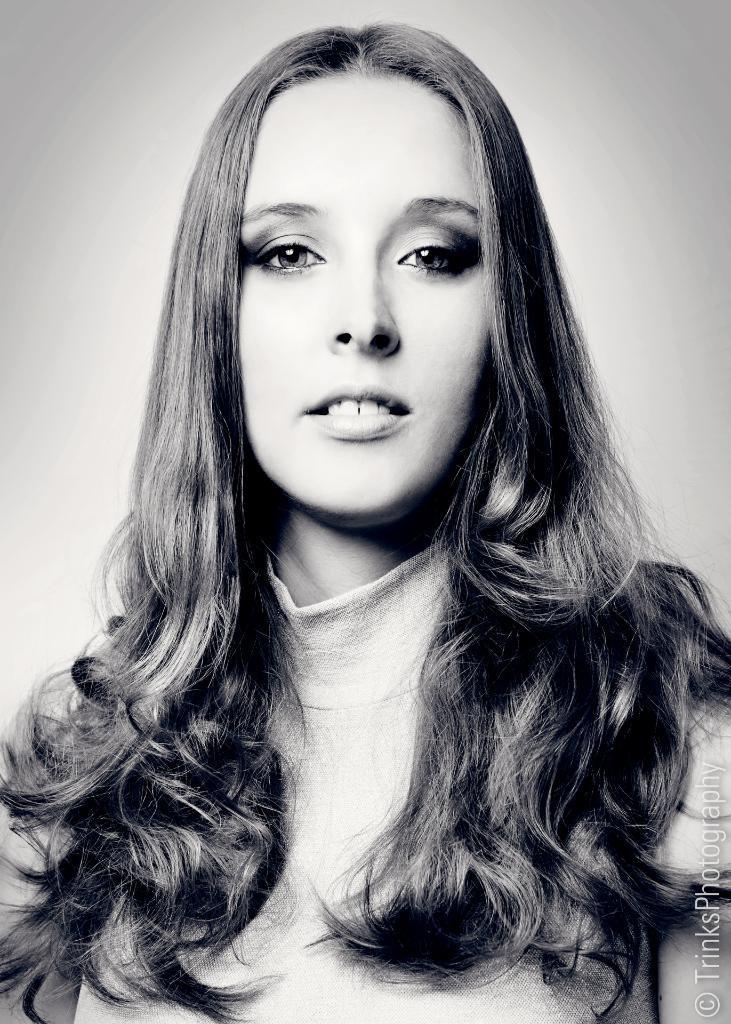Can you describe this image briefly? In this picture we can see a woman smiling and at the bottom right corner we can see some text. 